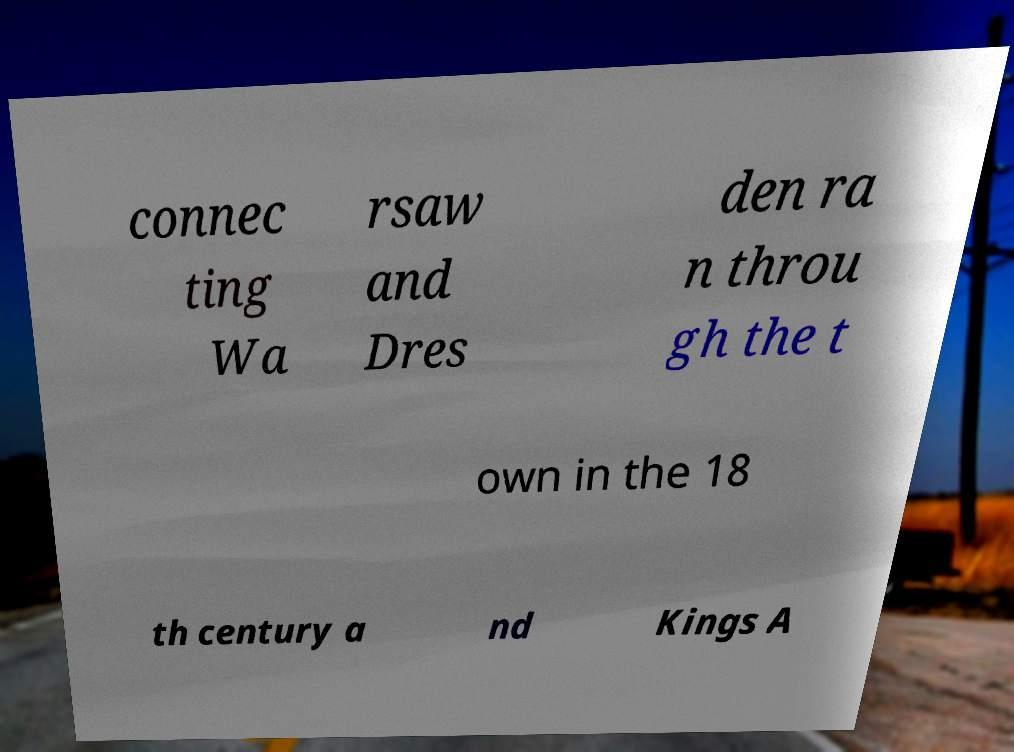Could you extract and type out the text from this image? connec ting Wa rsaw and Dres den ra n throu gh the t own in the 18 th century a nd Kings A 